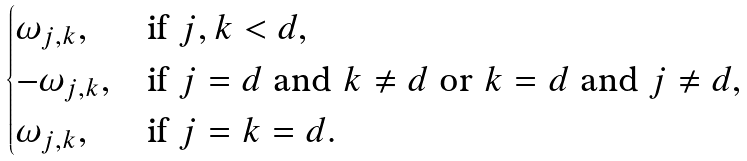Convert formula to latex. <formula><loc_0><loc_0><loc_500><loc_500>\begin{cases} \omega _ { j , k } , & \text {if } j , k < d , \\ - \omega _ { j , k } , & \text {if } j = d \text { and } k \neq d \text { or } k = d \text { and } j \neq d , \\ \omega _ { j , k } , & \text {if } j = k = d . \end{cases}</formula> 